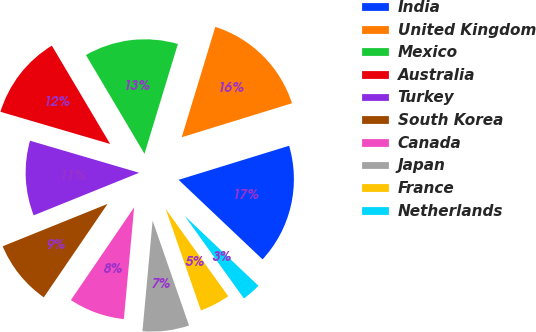Convert chart to OTSL. <chart><loc_0><loc_0><loc_500><loc_500><pie_chart><fcel>India<fcel>United Kingdom<fcel>Mexico<fcel>Australia<fcel>Turkey<fcel>South Korea<fcel>Canada<fcel>Japan<fcel>France<fcel>Netherlands<nl><fcel>16.83%<fcel>15.54%<fcel>13.22%<fcel>11.94%<fcel>10.65%<fcel>9.36%<fcel>8.07%<fcel>6.78%<fcel>4.58%<fcel>3.03%<nl></chart> 